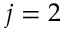Convert formula to latex. <formula><loc_0><loc_0><loc_500><loc_500>j = 2</formula> 